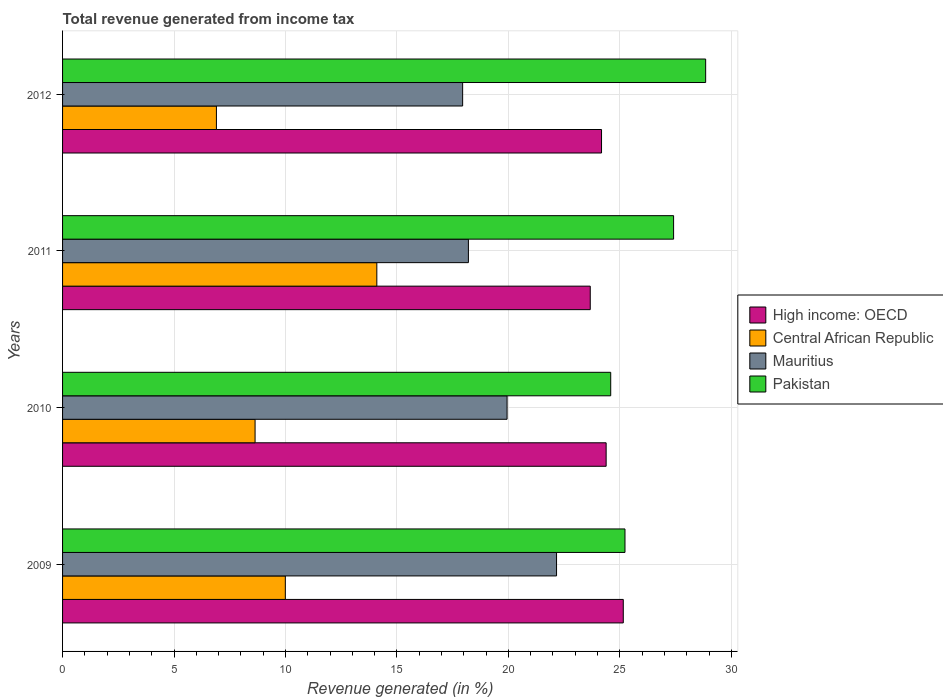Are the number of bars on each tick of the Y-axis equal?
Offer a terse response. Yes. How many bars are there on the 3rd tick from the top?
Offer a terse response. 4. How many bars are there on the 4th tick from the bottom?
Make the answer very short. 4. In how many cases, is the number of bars for a given year not equal to the number of legend labels?
Ensure brevity in your answer.  0. What is the total revenue generated in Mauritius in 2009?
Provide a short and direct response. 22.16. Across all years, what is the maximum total revenue generated in Pakistan?
Provide a succinct answer. 28.85. Across all years, what is the minimum total revenue generated in Central African Republic?
Your answer should be compact. 6.9. In which year was the total revenue generated in Central African Republic maximum?
Offer a very short reply. 2011. In which year was the total revenue generated in Pakistan minimum?
Your answer should be very brief. 2010. What is the total total revenue generated in High income: OECD in the graph?
Offer a very short reply. 97.39. What is the difference between the total revenue generated in Central African Republic in 2010 and that in 2012?
Your response must be concise. 1.73. What is the difference between the total revenue generated in Mauritius in 2010 and the total revenue generated in High income: OECD in 2011?
Provide a short and direct response. -3.73. What is the average total revenue generated in Pakistan per year?
Your answer should be very brief. 26.52. In the year 2009, what is the difference between the total revenue generated in Pakistan and total revenue generated in Mauritius?
Provide a short and direct response. 3.07. In how many years, is the total revenue generated in High income: OECD greater than 3 %?
Your answer should be very brief. 4. What is the ratio of the total revenue generated in Central African Republic in 2011 to that in 2012?
Your answer should be compact. 2.04. Is the total revenue generated in Central African Republic in 2011 less than that in 2012?
Your response must be concise. No. Is the difference between the total revenue generated in Pakistan in 2009 and 2011 greater than the difference between the total revenue generated in Mauritius in 2009 and 2011?
Make the answer very short. No. What is the difference between the highest and the second highest total revenue generated in Pakistan?
Your answer should be very brief. 1.44. What is the difference between the highest and the lowest total revenue generated in Mauritius?
Provide a succinct answer. 4.21. Is the sum of the total revenue generated in High income: OECD in 2009 and 2011 greater than the maximum total revenue generated in Pakistan across all years?
Keep it short and to the point. Yes. Is it the case that in every year, the sum of the total revenue generated in High income: OECD and total revenue generated in Central African Republic is greater than the sum of total revenue generated in Mauritius and total revenue generated in Pakistan?
Ensure brevity in your answer.  No. What does the 2nd bar from the bottom in 2011 represents?
Give a very brief answer. Central African Republic. Is it the case that in every year, the sum of the total revenue generated in Central African Republic and total revenue generated in Pakistan is greater than the total revenue generated in High income: OECD?
Ensure brevity in your answer.  Yes. Are all the bars in the graph horizontal?
Offer a very short reply. Yes. How many years are there in the graph?
Offer a terse response. 4. Does the graph contain grids?
Keep it short and to the point. Yes. How many legend labels are there?
Ensure brevity in your answer.  4. How are the legend labels stacked?
Your answer should be compact. Vertical. What is the title of the graph?
Make the answer very short. Total revenue generated from income tax. What is the label or title of the X-axis?
Your response must be concise. Revenue generated (in %). What is the label or title of the Y-axis?
Provide a short and direct response. Years. What is the Revenue generated (in %) of High income: OECD in 2009?
Make the answer very short. 25.15. What is the Revenue generated (in %) in Central African Republic in 2009?
Keep it short and to the point. 9.99. What is the Revenue generated (in %) in Mauritius in 2009?
Give a very brief answer. 22.16. What is the Revenue generated (in %) in Pakistan in 2009?
Provide a succinct answer. 25.23. What is the Revenue generated (in %) in High income: OECD in 2010?
Keep it short and to the point. 24.39. What is the Revenue generated (in %) in Central African Republic in 2010?
Provide a succinct answer. 8.64. What is the Revenue generated (in %) of Mauritius in 2010?
Keep it short and to the point. 19.94. What is the Revenue generated (in %) in Pakistan in 2010?
Your response must be concise. 24.59. What is the Revenue generated (in %) in High income: OECD in 2011?
Give a very brief answer. 23.67. What is the Revenue generated (in %) in Central African Republic in 2011?
Your answer should be very brief. 14.1. What is the Revenue generated (in %) of Mauritius in 2011?
Offer a terse response. 18.21. What is the Revenue generated (in %) of Pakistan in 2011?
Provide a succinct answer. 27.41. What is the Revenue generated (in %) of High income: OECD in 2012?
Keep it short and to the point. 24.18. What is the Revenue generated (in %) of Central African Republic in 2012?
Ensure brevity in your answer.  6.9. What is the Revenue generated (in %) of Mauritius in 2012?
Keep it short and to the point. 17.95. What is the Revenue generated (in %) of Pakistan in 2012?
Ensure brevity in your answer.  28.85. Across all years, what is the maximum Revenue generated (in %) in High income: OECD?
Make the answer very short. 25.15. Across all years, what is the maximum Revenue generated (in %) of Central African Republic?
Your answer should be compact. 14.1. Across all years, what is the maximum Revenue generated (in %) of Mauritius?
Provide a short and direct response. 22.16. Across all years, what is the maximum Revenue generated (in %) of Pakistan?
Offer a terse response. 28.85. Across all years, what is the minimum Revenue generated (in %) in High income: OECD?
Offer a terse response. 23.67. Across all years, what is the minimum Revenue generated (in %) in Central African Republic?
Your answer should be compact. 6.9. Across all years, what is the minimum Revenue generated (in %) in Mauritius?
Keep it short and to the point. 17.95. Across all years, what is the minimum Revenue generated (in %) of Pakistan?
Ensure brevity in your answer.  24.59. What is the total Revenue generated (in %) in High income: OECD in the graph?
Your answer should be very brief. 97.39. What is the total Revenue generated (in %) of Central African Republic in the graph?
Your answer should be compact. 39.63. What is the total Revenue generated (in %) of Mauritius in the graph?
Offer a very short reply. 78.26. What is the total Revenue generated (in %) of Pakistan in the graph?
Provide a short and direct response. 106.08. What is the difference between the Revenue generated (in %) in High income: OECD in 2009 and that in 2010?
Ensure brevity in your answer.  0.77. What is the difference between the Revenue generated (in %) in Central African Republic in 2009 and that in 2010?
Ensure brevity in your answer.  1.36. What is the difference between the Revenue generated (in %) of Mauritius in 2009 and that in 2010?
Provide a succinct answer. 2.22. What is the difference between the Revenue generated (in %) in Pakistan in 2009 and that in 2010?
Your answer should be compact. 0.64. What is the difference between the Revenue generated (in %) in High income: OECD in 2009 and that in 2011?
Give a very brief answer. 1.48. What is the difference between the Revenue generated (in %) in Central African Republic in 2009 and that in 2011?
Keep it short and to the point. -4.1. What is the difference between the Revenue generated (in %) of Mauritius in 2009 and that in 2011?
Give a very brief answer. 3.95. What is the difference between the Revenue generated (in %) in Pakistan in 2009 and that in 2011?
Ensure brevity in your answer.  -2.18. What is the difference between the Revenue generated (in %) in High income: OECD in 2009 and that in 2012?
Your answer should be very brief. 0.98. What is the difference between the Revenue generated (in %) in Central African Republic in 2009 and that in 2012?
Your response must be concise. 3.09. What is the difference between the Revenue generated (in %) of Mauritius in 2009 and that in 2012?
Offer a terse response. 4.21. What is the difference between the Revenue generated (in %) of Pakistan in 2009 and that in 2012?
Offer a terse response. -3.62. What is the difference between the Revenue generated (in %) in High income: OECD in 2010 and that in 2011?
Make the answer very short. 0.71. What is the difference between the Revenue generated (in %) in Central African Republic in 2010 and that in 2011?
Make the answer very short. -5.46. What is the difference between the Revenue generated (in %) in Mauritius in 2010 and that in 2011?
Your answer should be compact. 1.73. What is the difference between the Revenue generated (in %) of Pakistan in 2010 and that in 2011?
Give a very brief answer. -2.82. What is the difference between the Revenue generated (in %) of High income: OECD in 2010 and that in 2012?
Make the answer very short. 0.21. What is the difference between the Revenue generated (in %) of Central African Republic in 2010 and that in 2012?
Offer a terse response. 1.73. What is the difference between the Revenue generated (in %) of Mauritius in 2010 and that in 2012?
Provide a short and direct response. 1.99. What is the difference between the Revenue generated (in %) of Pakistan in 2010 and that in 2012?
Ensure brevity in your answer.  -4.26. What is the difference between the Revenue generated (in %) of High income: OECD in 2011 and that in 2012?
Make the answer very short. -0.51. What is the difference between the Revenue generated (in %) of Central African Republic in 2011 and that in 2012?
Offer a terse response. 7.2. What is the difference between the Revenue generated (in %) of Mauritius in 2011 and that in 2012?
Your response must be concise. 0.26. What is the difference between the Revenue generated (in %) in Pakistan in 2011 and that in 2012?
Keep it short and to the point. -1.44. What is the difference between the Revenue generated (in %) in High income: OECD in 2009 and the Revenue generated (in %) in Central African Republic in 2010?
Your answer should be very brief. 16.52. What is the difference between the Revenue generated (in %) of High income: OECD in 2009 and the Revenue generated (in %) of Mauritius in 2010?
Give a very brief answer. 5.21. What is the difference between the Revenue generated (in %) in High income: OECD in 2009 and the Revenue generated (in %) in Pakistan in 2010?
Provide a succinct answer. 0.56. What is the difference between the Revenue generated (in %) in Central African Republic in 2009 and the Revenue generated (in %) in Mauritius in 2010?
Provide a succinct answer. -9.95. What is the difference between the Revenue generated (in %) of Central African Republic in 2009 and the Revenue generated (in %) of Pakistan in 2010?
Keep it short and to the point. -14.6. What is the difference between the Revenue generated (in %) of Mauritius in 2009 and the Revenue generated (in %) of Pakistan in 2010?
Your answer should be compact. -2.43. What is the difference between the Revenue generated (in %) of High income: OECD in 2009 and the Revenue generated (in %) of Central African Republic in 2011?
Provide a succinct answer. 11.06. What is the difference between the Revenue generated (in %) of High income: OECD in 2009 and the Revenue generated (in %) of Mauritius in 2011?
Provide a short and direct response. 6.95. What is the difference between the Revenue generated (in %) in High income: OECD in 2009 and the Revenue generated (in %) in Pakistan in 2011?
Your answer should be compact. -2.26. What is the difference between the Revenue generated (in %) of Central African Republic in 2009 and the Revenue generated (in %) of Mauritius in 2011?
Provide a succinct answer. -8.21. What is the difference between the Revenue generated (in %) of Central African Republic in 2009 and the Revenue generated (in %) of Pakistan in 2011?
Your response must be concise. -17.42. What is the difference between the Revenue generated (in %) in Mauritius in 2009 and the Revenue generated (in %) in Pakistan in 2011?
Ensure brevity in your answer.  -5.25. What is the difference between the Revenue generated (in %) of High income: OECD in 2009 and the Revenue generated (in %) of Central African Republic in 2012?
Give a very brief answer. 18.25. What is the difference between the Revenue generated (in %) of High income: OECD in 2009 and the Revenue generated (in %) of Mauritius in 2012?
Give a very brief answer. 7.21. What is the difference between the Revenue generated (in %) in High income: OECD in 2009 and the Revenue generated (in %) in Pakistan in 2012?
Provide a succinct answer. -3.69. What is the difference between the Revenue generated (in %) of Central African Republic in 2009 and the Revenue generated (in %) of Mauritius in 2012?
Keep it short and to the point. -7.95. What is the difference between the Revenue generated (in %) in Central African Republic in 2009 and the Revenue generated (in %) in Pakistan in 2012?
Your response must be concise. -18.86. What is the difference between the Revenue generated (in %) of Mauritius in 2009 and the Revenue generated (in %) of Pakistan in 2012?
Provide a succinct answer. -6.69. What is the difference between the Revenue generated (in %) of High income: OECD in 2010 and the Revenue generated (in %) of Central African Republic in 2011?
Ensure brevity in your answer.  10.29. What is the difference between the Revenue generated (in %) in High income: OECD in 2010 and the Revenue generated (in %) in Mauritius in 2011?
Make the answer very short. 6.18. What is the difference between the Revenue generated (in %) in High income: OECD in 2010 and the Revenue generated (in %) in Pakistan in 2011?
Make the answer very short. -3.03. What is the difference between the Revenue generated (in %) in Central African Republic in 2010 and the Revenue generated (in %) in Mauritius in 2011?
Provide a succinct answer. -9.57. What is the difference between the Revenue generated (in %) of Central African Republic in 2010 and the Revenue generated (in %) of Pakistan in 2011?
Your response must be concise. -18.77. What is the difference between the Revenue generated (in %) in Mauritius in 2010 and the Revenue generated (in %) in Pakistan in 2011?
Your answer should be compact. -7.47. What is the difference between the Revenue generated (in %) in High income: OECD in 2010 and the Revenue generated (in %) in Central African Republic in 2012?
Your answer should be very brief. 17.48. What is the difference between the Revenue generated (in %) of High income: OECD in 2010 and the Revenue generated (in %) of Mauritius in 2012?
Give a very brief answer. 6.44. What is the difference between the Revenue generated (in %) of High income: OECD in 2010 and the Revenue generated (in %) of Pakistan in 2012?
Provide a succinct answer. -4.46. What is the difference between the Revenue generated (in %) in Central African Republic in 2010 and the Revenue generated (in %) in Mauritius in 2012?
Provide a short and direct response. -9.31. What is the difference between the Revenue generated (in %) in Central African Republic in 2010 and the Revenue generated (in %) in Pakistan in 2012?
Provide a succinct answer. -20.21. What is the difference between the Revenue generated (in %) in Mauritius in 2010 and the Revenue generated (in %) in Pakistan in 2012?
Your response must be concise. -8.91. What is the difference between the Revenue generated (in %) in High income: OECD in 2011 and the Revenue generated (in %) in Central African Republic in 2012?
Your answer should be compact. 16.77. What is the difference between the Revenue generated (in %) in High income: OECD in 2011 and the Revenue generated (in %) in Mauritius in 2012?
Provide a succinct answer. 5.73. What is the difference between the Revenue generated (in %) of High income: OECD in 2011 and the Revenue generated (in %) of Pakistan in 2012?
Ensure brevity in your answer.  -5.18. What is the difference between the Revenue generated (in %) of Central African Republic in 2011 and the Revenue generated (in %) of Mauritius in 2012?
Ensure brevity in your answer.  -3.85. What is the difference between the Revenue generated (in %) in Central African Republic in 2011 and the Revenue generated (in %) in Pakistan in 2012?
Offer a very short reply. -14.75. What is the difference between the Revenue generated (in %) in Mauritius in 2011 and the Revenue generated (in %) in Pakistan in 2012?
Ensure brevity in your answer.  -10.64. What is the average Revenue generated (in %) in High income: OECD per year?
Provide a succinct answer. 24.35. What is the average Revenue generated (in %) in Central African Republic per year?
Provide a succinct answer. 9.91. What is the average Revenue generated (in %) of Mauritius per year?
Give a very brief answer. 19.56. What is the average Revenue generated (in %) of Pakistan per year?
Offer a terse response. 26.52. In the year 2009, what is the difference between the Revenue generated (in %) in High income: OECD and Revenue generated (in %) in Central African Republic?
Offer a very short reply. 15.16. In the year 2009, what is the difference between the Revenue generated (in %) in High income: OECD and Revenue generated (in %) in Mauritius?
Make the answer very short. 2.99. In the year 2009, what is the difference between the Revenue generated (in %) of High income: OECD and Revenue generated (in %) of Pakistan?
Ensure brevity in your answer.  -0.08. In the year 2009, what is the difference between the Revenue generated (in %) of Central African Republic and Revenue generated (in %) of Mauritius?
Provide a short and direct response. -12.17. In the year 2009, what is the difference between the Revenue generated (in %) of Central African Republic and Revenue generated (in %) of Pakistan?
Your answer should be very brief. -15.24. In the year 2009, what is the difference between the Revenue generated (in %) of Mauritius and Revenue generated (in %) of Pakistan?
Provide a succinct answer. -3.07. In the year 2010, what is the difference between the Revenue generated (in %) in High income: OECD and Revenue generated (in %) in Central African Republic?
Keep it short and to the point. 15.75. In the year 2010, what is the difference between the Revenue generated (in %) in High income: OECD and Revenue generated (in %) in Mauritius?
Provide a short and direct response. 4.44. In the year 2010, what is the difference between the Revenue generated (in %) in High income: OECD and Revenue generated (in %) in Pakistan?
Give a very brief answer. -0.21. In the year 2010, what is the difference between the Revenue generated (in %) in Central African Republic and Revenue generated (in %) in Mauritius?
Ensure brevity in your answer.  -11.3. In the year 2010, what is the difference between the Revenue generated (in %) in Central African Republic and Revenue generated (in %) in Pakistan?
Provide a short and direct response. -15.95. In the year 2010, what is the difference between the Revenue generated (in %) in Mauritius and Revenue generated (in %) in Pakistan?
Offer a very short reply. -4.65. In the year 2011, what is the difference between the Revenue generated (in %) of High income: OECD and Revenue generated (in %) of Central African Republic?
Offer a terse response. 9.57. In the year 2011, what is the difference between the Revenue generated (in %) in High income: OECD and Revenue generated (in %) in Mauritius?
Keep it short and to the point. 5.47. In the year 2011, what is the difference between the Revenue generated (in %) of High income: OECD and Revenue generated (in %) of Pakistan?
Your response must be concise. -3.74. In the year 2011, what is the difference between the Revenue generated (in %) of Central African Republic and Revenue generated (in %) of Mauritius?
Your response must be concise. -4.11. In the year 2011, what is the difference between the Revenue generated (in %) of Central African Republic and Revenue generated (in %) of Pakistan?
Provide a succinct answer. -13.31. In the year 2011, what is the difference between the Revenue generated (in %) of Mauritius and Revenue generated (in %) of Pakistan?
Keep it short and to the point. -9.2. In the year 2012, what is the difference between the Revenue generated (in %) in High income: OECD and Revenue generated (in %) in Central African Republic?
Provide a short and direct response. 17.28. In the year 2012, what is the difference between the Revenue generated (in %) in High income: OECD and Revenue generated (in %) in Mauritius?
Ensure brevity in your answer.  6.23. In the year 2012, what is the difference between the Revenue generated (in %) of High income: OECD and Revenue generated (in %) of Pakistan?
Offer a terse response. -4.67. In the year 2012, what is the difference between the Revenue generated (in %) in Central African Republic and Revenue generated (in %) in Mauritius?
Ensure brevity in your answer.  -11.05. In the year 2012, what is the difference between the Revenue generated (in %) of Central African Republic and Revenue generated (in %) of Pakistan?
Your response must be concise. -21.95. In the year 2012, what is the difference between the Revenue generated (in %) in Mauritius and Revenue generated (in %) in Pakistan?
Your answer should be very brief. -10.9. What is the ratio of the Revenue generated (in %) of High income: OECD in 2009 to that in 2010?
Your response must be concise. 1.03. What is the ratio of the Revenue generated (in %) in Central African Republic in 2009 to that in 2010?
Make the answer very short. 1.16. What is the ratio of the Revenue generated (in %) of Mauritius in 2009 to that in 2010?
Your answer should be very brief. 1.11. What is the ratio of the Revenue generated (in %) in High income: OECD in 2009 to that in 2011?
Your response must be concise. 1.06. What is the ratio of the Revenue generated (in %) in Central African Republic in 2009 to that in 2011?
Provide a succinct answer. 0.71. What is the ratio of the Revenue generated (in %) of Mauritius in 2009 to that in 2011?
Provide a short and direct response. 1.22. What is the ratio of the Revenue generated (in %) of Pakistan in 2009 to that in 2011?
Provide a short and direct response. 0.92. What is the ratio of the Revenue generated (in %) in High income: OECD in 2009 to that in 2012?
Give a very brief answer. 1.04. What is the ratio of the Revenue generated (in %) of Central African Republic in 2009 to that in 2012?
Keep it short and to the point. 1.45. What is the ratio of the Revenue generated (in %) of Mauritius in 2009 to that in 2012?
Your response must be concise. 1.23. What is the ratio of the Revenue generated (in %) of Pakistan in 2009 to that in 2012?
Your answer should be very brief. 0.87. What is the ratio of the Revenue generated (in %) of High income: OECD in 2010 to that in 2011?
Provide a short and direct response. 1.03. What is the ratio of the Revenue generated (in %) in Central African Republic in 2010 to that in 2011?
Offer a terse response. 0.61. What is the ratio of the Revenue generated (in %) of Mauritius in 2010 to that in 2011?
Your response must be concise. 1.1. What is the ratio of the Revenue generated (in %) of Pakistan in 2010 to that in 2011?
Offer a very short reply. 0.9. What is the ratio of the Revenue generated (in %) of High income: OECD in 2010 to that in 2012?
Give a very brief answer. 1.01. What is the ratio of the Revenue generated (in %) in Central African Republic in 2010 to that in 2012?
Ensure brevity in your answer.  1.25. What is the ratio of the Revenue generated (in %) in Mauritius in 2010 to that in 2012?
Ensure brevity in your answer.  1.11. What is the ratio of the Revenue generated (in %) in Pakistan in 2010 to that in 2012?
Your answer should be very brief. 0.85. What is the ratio of the Revenue generated (in %) in High income: OECD in 2011 to that in 2012?
Give a very brief answer. 0.98. What is the ratio of the Revenue generated (in %) in Central African Republic in 2011 to that in 2012?
Your answer should be compact. 2.04. What is the ratio of the Revenue generated (in %) in Mauritius in 2011 to that in 2012?
Give a very brief answer. 1.01. What is the ratio of the Revenue generated (in %) of Pakistan in 2011 to that in 2012?
Offer a very short reply. 0.95. What is the difference between the highest and the second highest Revenue generated (in %) of High income: OECD?
Make the answer very short. 0.77. What is the difference between the highest and the second highest Revenue generated (in %) of Central African Republic?
Provide a succinct answer. 4.1. What is the difference between the highest and the second highest Revenue generated (in %) of Mauritius?
Provide a succinct answer. 2.22. What is the difference between the highest and the second highest Revenue generated (in %) of Pakistan?
Make the answer very short. 1.44. What is the difference between the highest and the lowest Revenue generated (in %) of High income: OECD?
Your response must be concise. 1.48. What is the difference between the highest and the lowest Revenue generated (in %) of Central African Republic?
Ensure brevity in your answer.  7.2. What is the difference between the highest and the lowest Revenue generated (in %) in Mauritius?
Ensure brevity in your answer.  4.21. What is the difference between the highest and the lowest Revenue generated (in %) in Pakistan?
Provide a succinct answer. 4.26. 